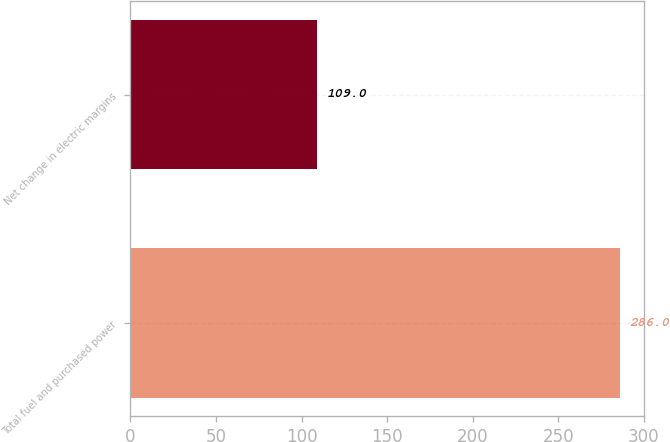Convert chart. <chart><loc_0><loc_0><loc_500><loc_500><bar_chart><fcel>Total fuel and purchased power<fcel>Net change in electric margins<nl><fcel>286<fcel>109<nl></chart> 